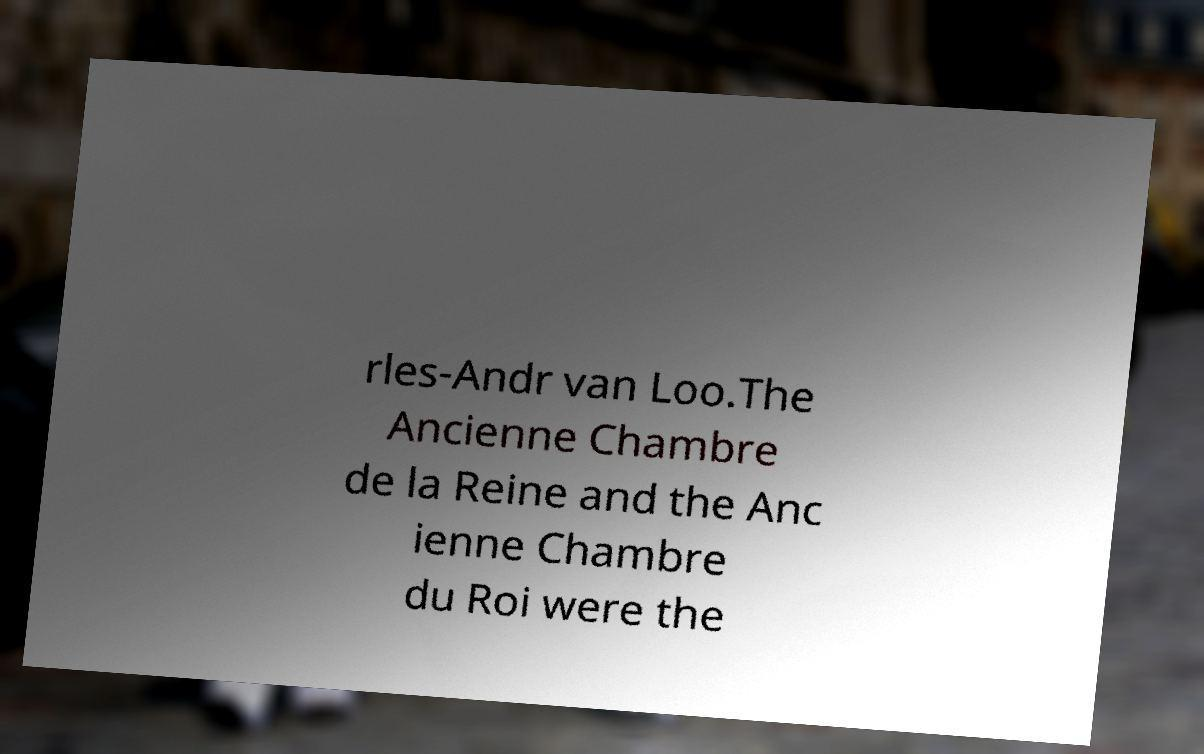For documentation purposes, I need the text within this image transcribed. Could you provide that? rles-Andr van Loo.The Ancienne Chambre de la Reine and the Anc ienne Chambre du Roi were the 